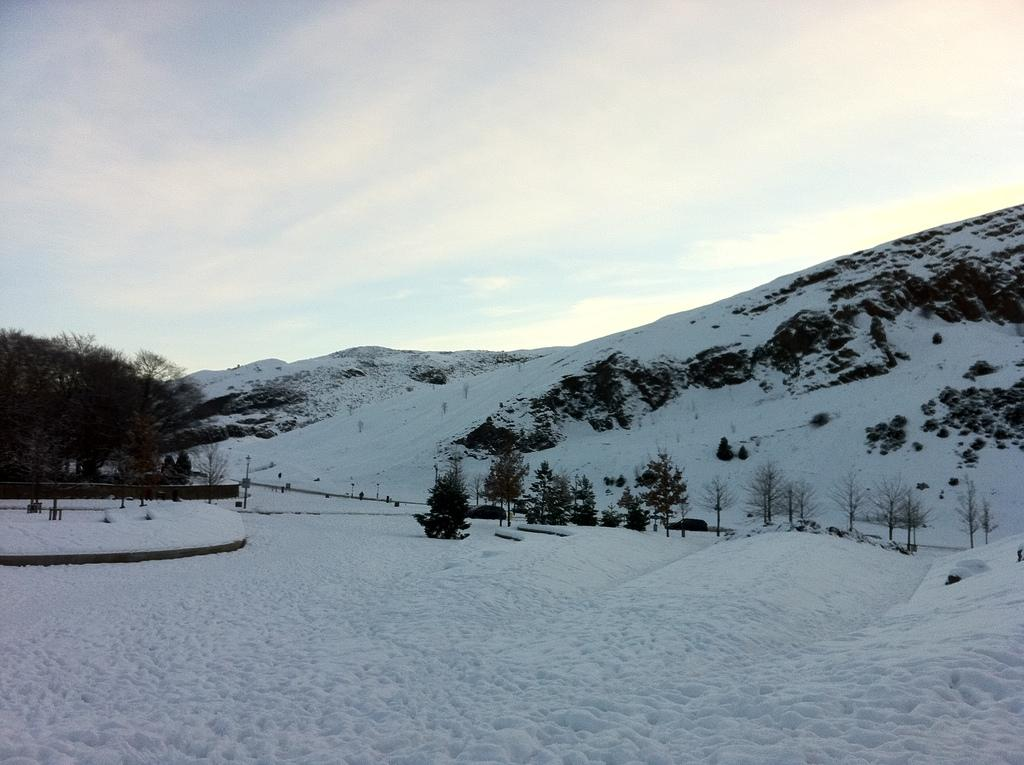What type of surface is visible at the bottom of the image? There is a snow surface at the bottom of the image. What can be seen in the background of the image? There are trees, mountains, and clouds in the sky in the background of the image. How many jellyfish can be seen swimming in the snow surface in the image? There are no jellyfish present in the image; it features a snow surface with trees, mountains, and clouds in the background. 